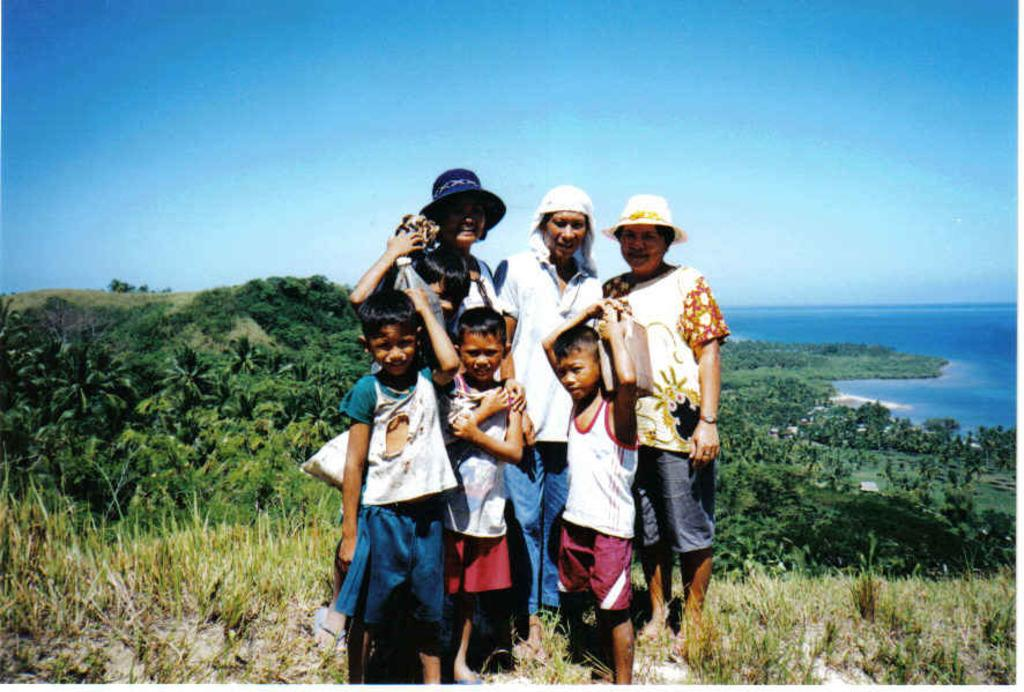How many people are in the image? There is a group of people in the image. What is the position of the people in the image? The people are standing on the ground. What can be seen in the background of the image? There are trees, water, and the sky visible in the background of the image. What type of rice is being served to the grandmother in the image? There is no grandmother or rice present in the image. 